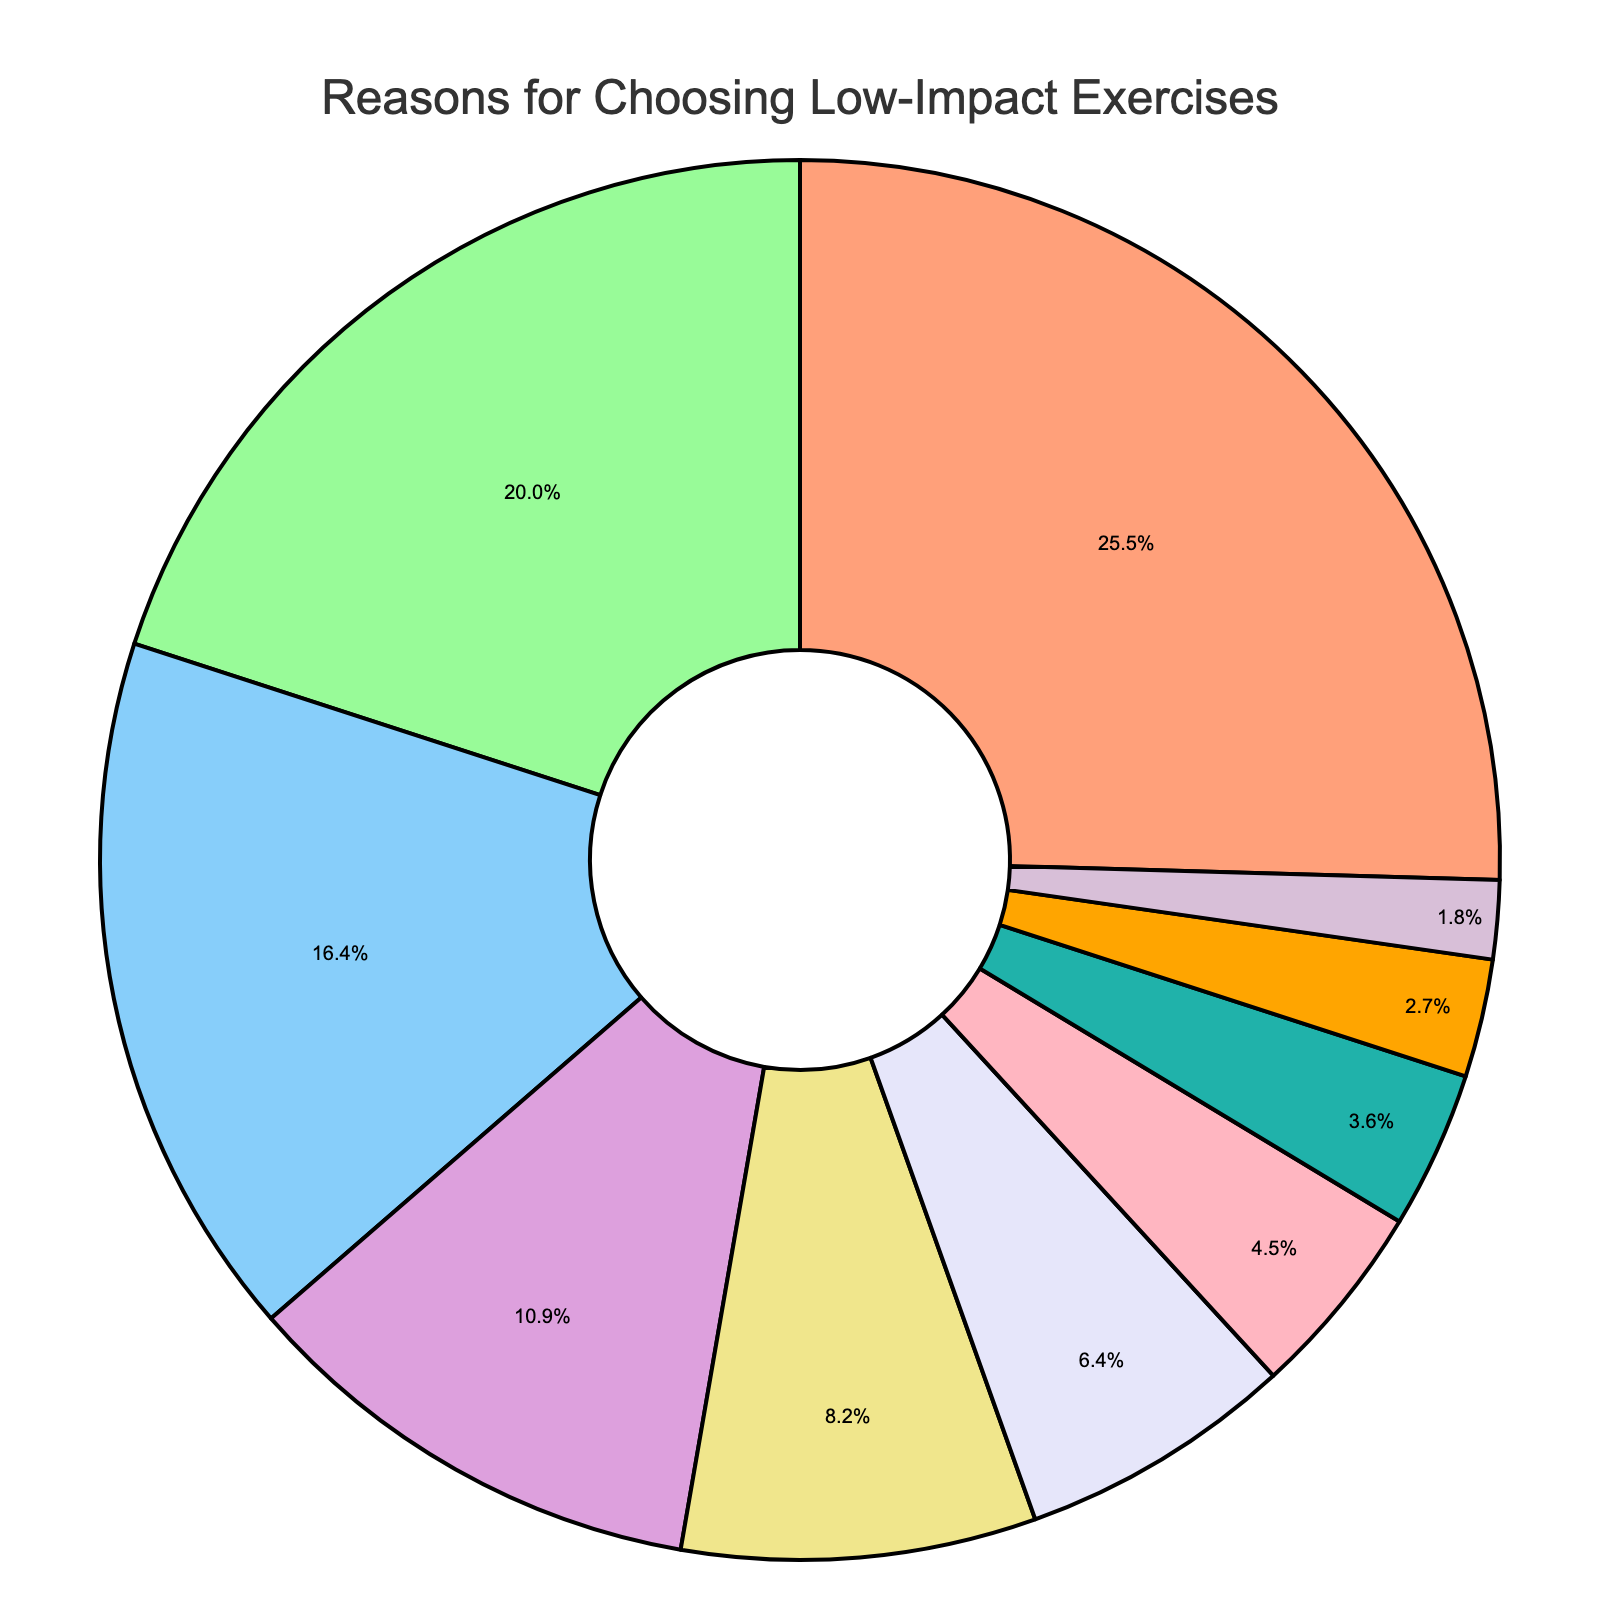Which reason is the most common for choosing low-impact exercises over high-intensity workouts? The segment with the largest percentage represents the most common reason. The "Joint health and injury prevention" segment is the largest, with 28%.
Answer: Joint health and injury prevention How much more common is reducing stress and relaxation compared to the mind-body connection? To find this, subtract the percentage for "Better mind-body connection" from "Stress reduction and relaxation". 22% - 9% = 13%.
Answer: 13% What is the combined percentage of reasons related to long-term sustainability (Easier to maintain long-term and Lower risk of burnout)? Add the percentages for "Easier to maintain long-term" and "Lower risk of burnout". 7% + 5% = 12%.
Answer: 12% Among all reasons, which one has the smallest percentage? The segment with the smallest percentage represents the least common reason. "Adaptable to personal limitations" has the smallest percentage at 2%.
Answer: Adaptable to personal limitations Are the percentages of reasons related to gradual fitness improvement and being suitable for all age groups greater than 20% when combined? Add the percentages for "Gradual fitness improvement" and "Suitable for all age groups". 18% + 12% = 30%, which is greater than 20%.
Answer: Yes Which reasons contribute to a better mind-body connection and more enjoyment and sustainability have a combined percentage? Add the percentages for "Better mind-body connection" and "More enjoyable and sustainable". 9% + 3% = 12%.
Answer: 12% Is the percentage for stress reduction and relaxation more than double that of better mind-body connection? Double the percentage for "Better mind-body connection" and compare it to "Stress reduction and relaxation". 9% * 2 = 18% is less than 22%.
Answer: Yes If you combine the benefits of being age-appropriate and gentle on the cardiovascular system, how does this total compare to the percentage for joint health and injury prevention? Add the percentages for "Suitable for all age groups" and "Gentle on cardiovascular system" and compare to "Joint health and injury prevention". 12% + 4% = 16%, less than 28%.
Answer: Less What is the ratio of the percentage of joint health and injury prevention to the percentage of lower risk of burnout? Divide the percentage for "Joint health and injury prevention" by "Lower risk of burnout". 28% / 5% = 5.6.
Answer: 5.6 Which reason has a percentage closest to 10%? The segment with the percentage closest to 10% is "Better mind-body connection", which has a percentage of 9%.
Answer: Better mind-body connection 